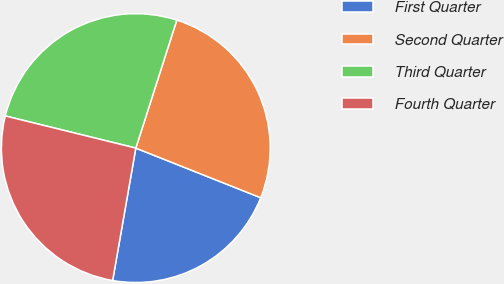<chart> <loc_0><loc_0><loc_500><loc_500><pie_chart><fcel>First Quarter<fcel>Second Quarter<fcel>Third Quarter<fcel>Fourth Quarter<nl><fcel>21.74%<fcel>26.09%<fcel>26.09%<fcel>26.09%<nl></chart> 